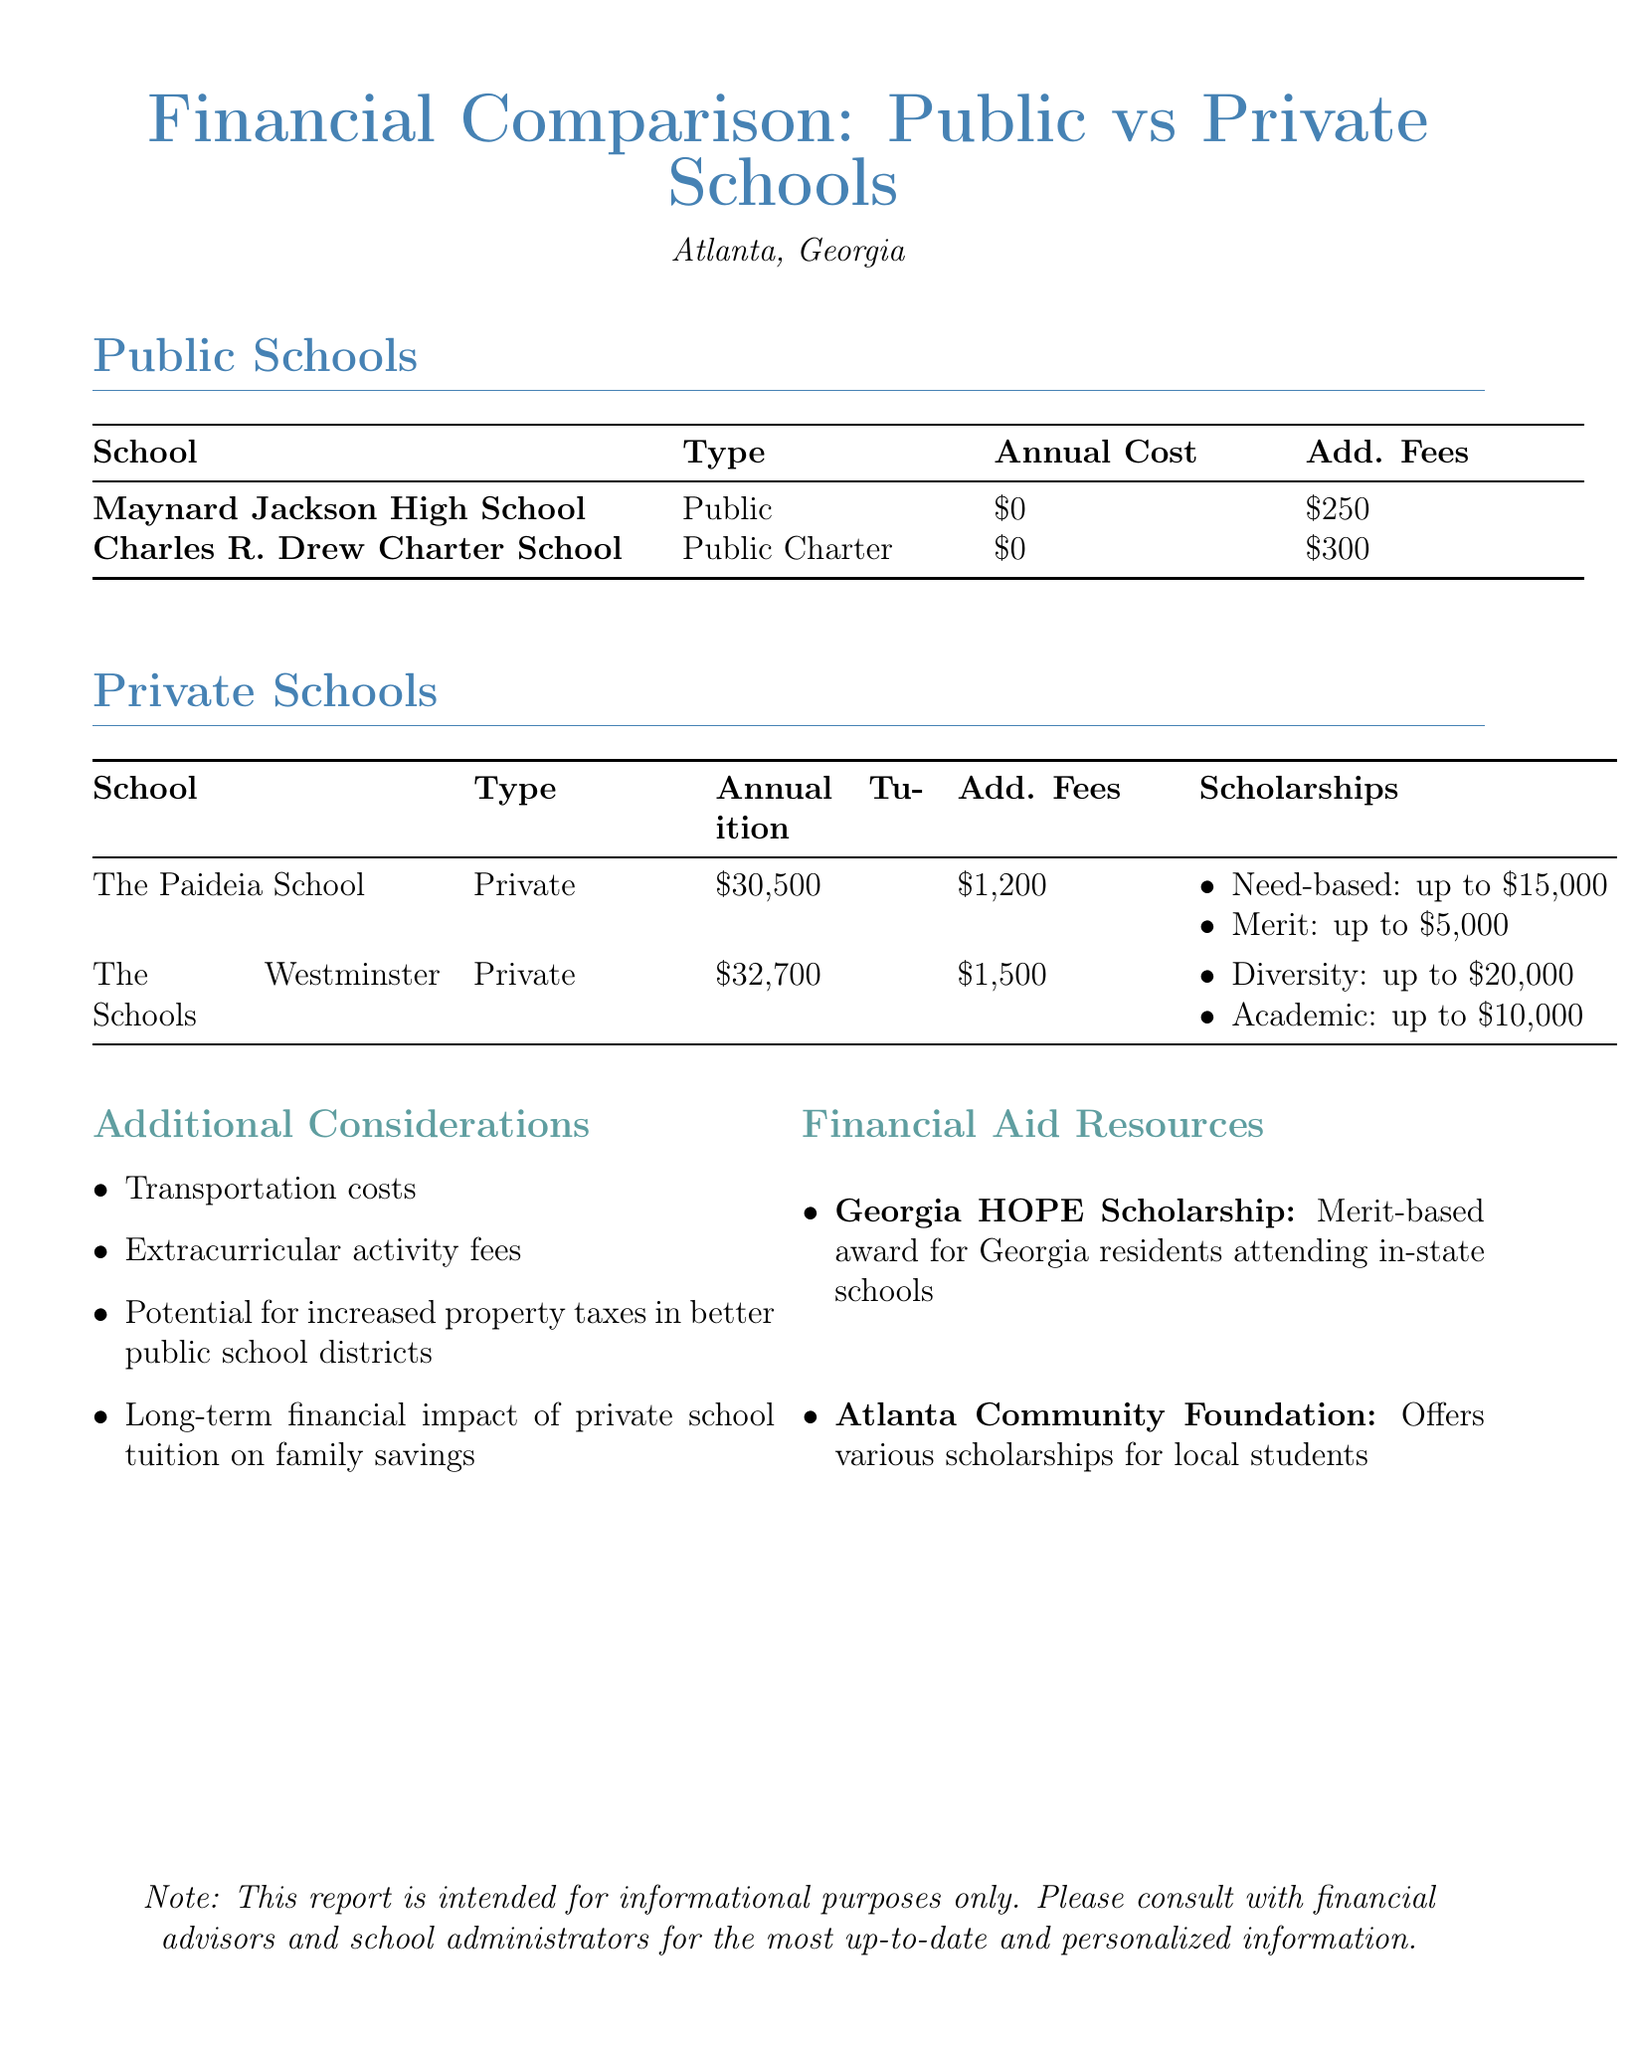What is the annual cost for Maynard Jackson High School? The annual cost for Maynard Jackson High School is listed in the document as zero dollars.
Answer: $0 What is the additional fee for Charles R. Drew Charter School? The additional fee listed for Charles R. Drew Charter School is $300.
Answer: $300 What is the maximum amount for the Need-based Financial Aid scholarship at The Paideia School? The document states that the maximum amount for the Need-based Financial Aid scholarship at The Paideia School is $15,000.
Answer: $15,000 How much is the annual tuition for The Westminster Schools? The annual tuition for The Westminster Schools is provided in the document as $32,700.
Answer: $32,700 What are the additional considerations when comparing school options? The document lists factors such as transportation costs and the impact of private school tuition on family savings as additional considerations.
Answer: Transportation costs, Extracurricular activity fees, Potential for increased property taxes, Long-term financial impact How many scholarships are mentioned for The Paideia School? The document mentions two types of scholarships available for The Paideia School.
Answer: 2 What type of school is Charles R. Drew Charter School? The type of Charles R. Drew Charter School is identified in the document as a Public Charter.
Answer: Public Charter What is the purpose of the Georgia HOPE Scholarship? The document states that the Georgia HOPE Scholarship is a merit-based award for Georgia residents.
Answer: Merit-based award for Georgia residents 